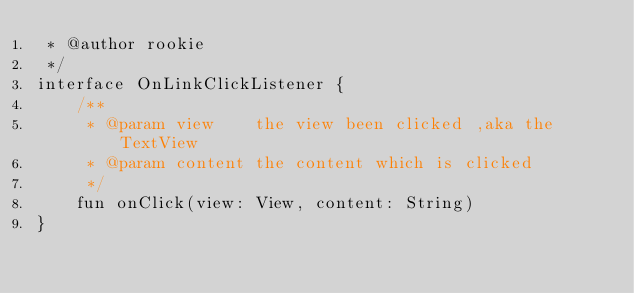Convert code to text. <code><loc_0><loc_0><loc_500><loc_500><_Kotlin_> * @author rookie
 */
interface OnLinkClickListener {
    /**
     * @param view    the view been clicked ,aka the TextView
     * @param content the content which is clicked
     */
    fun onClick(view: View, content: String)
}</code> 